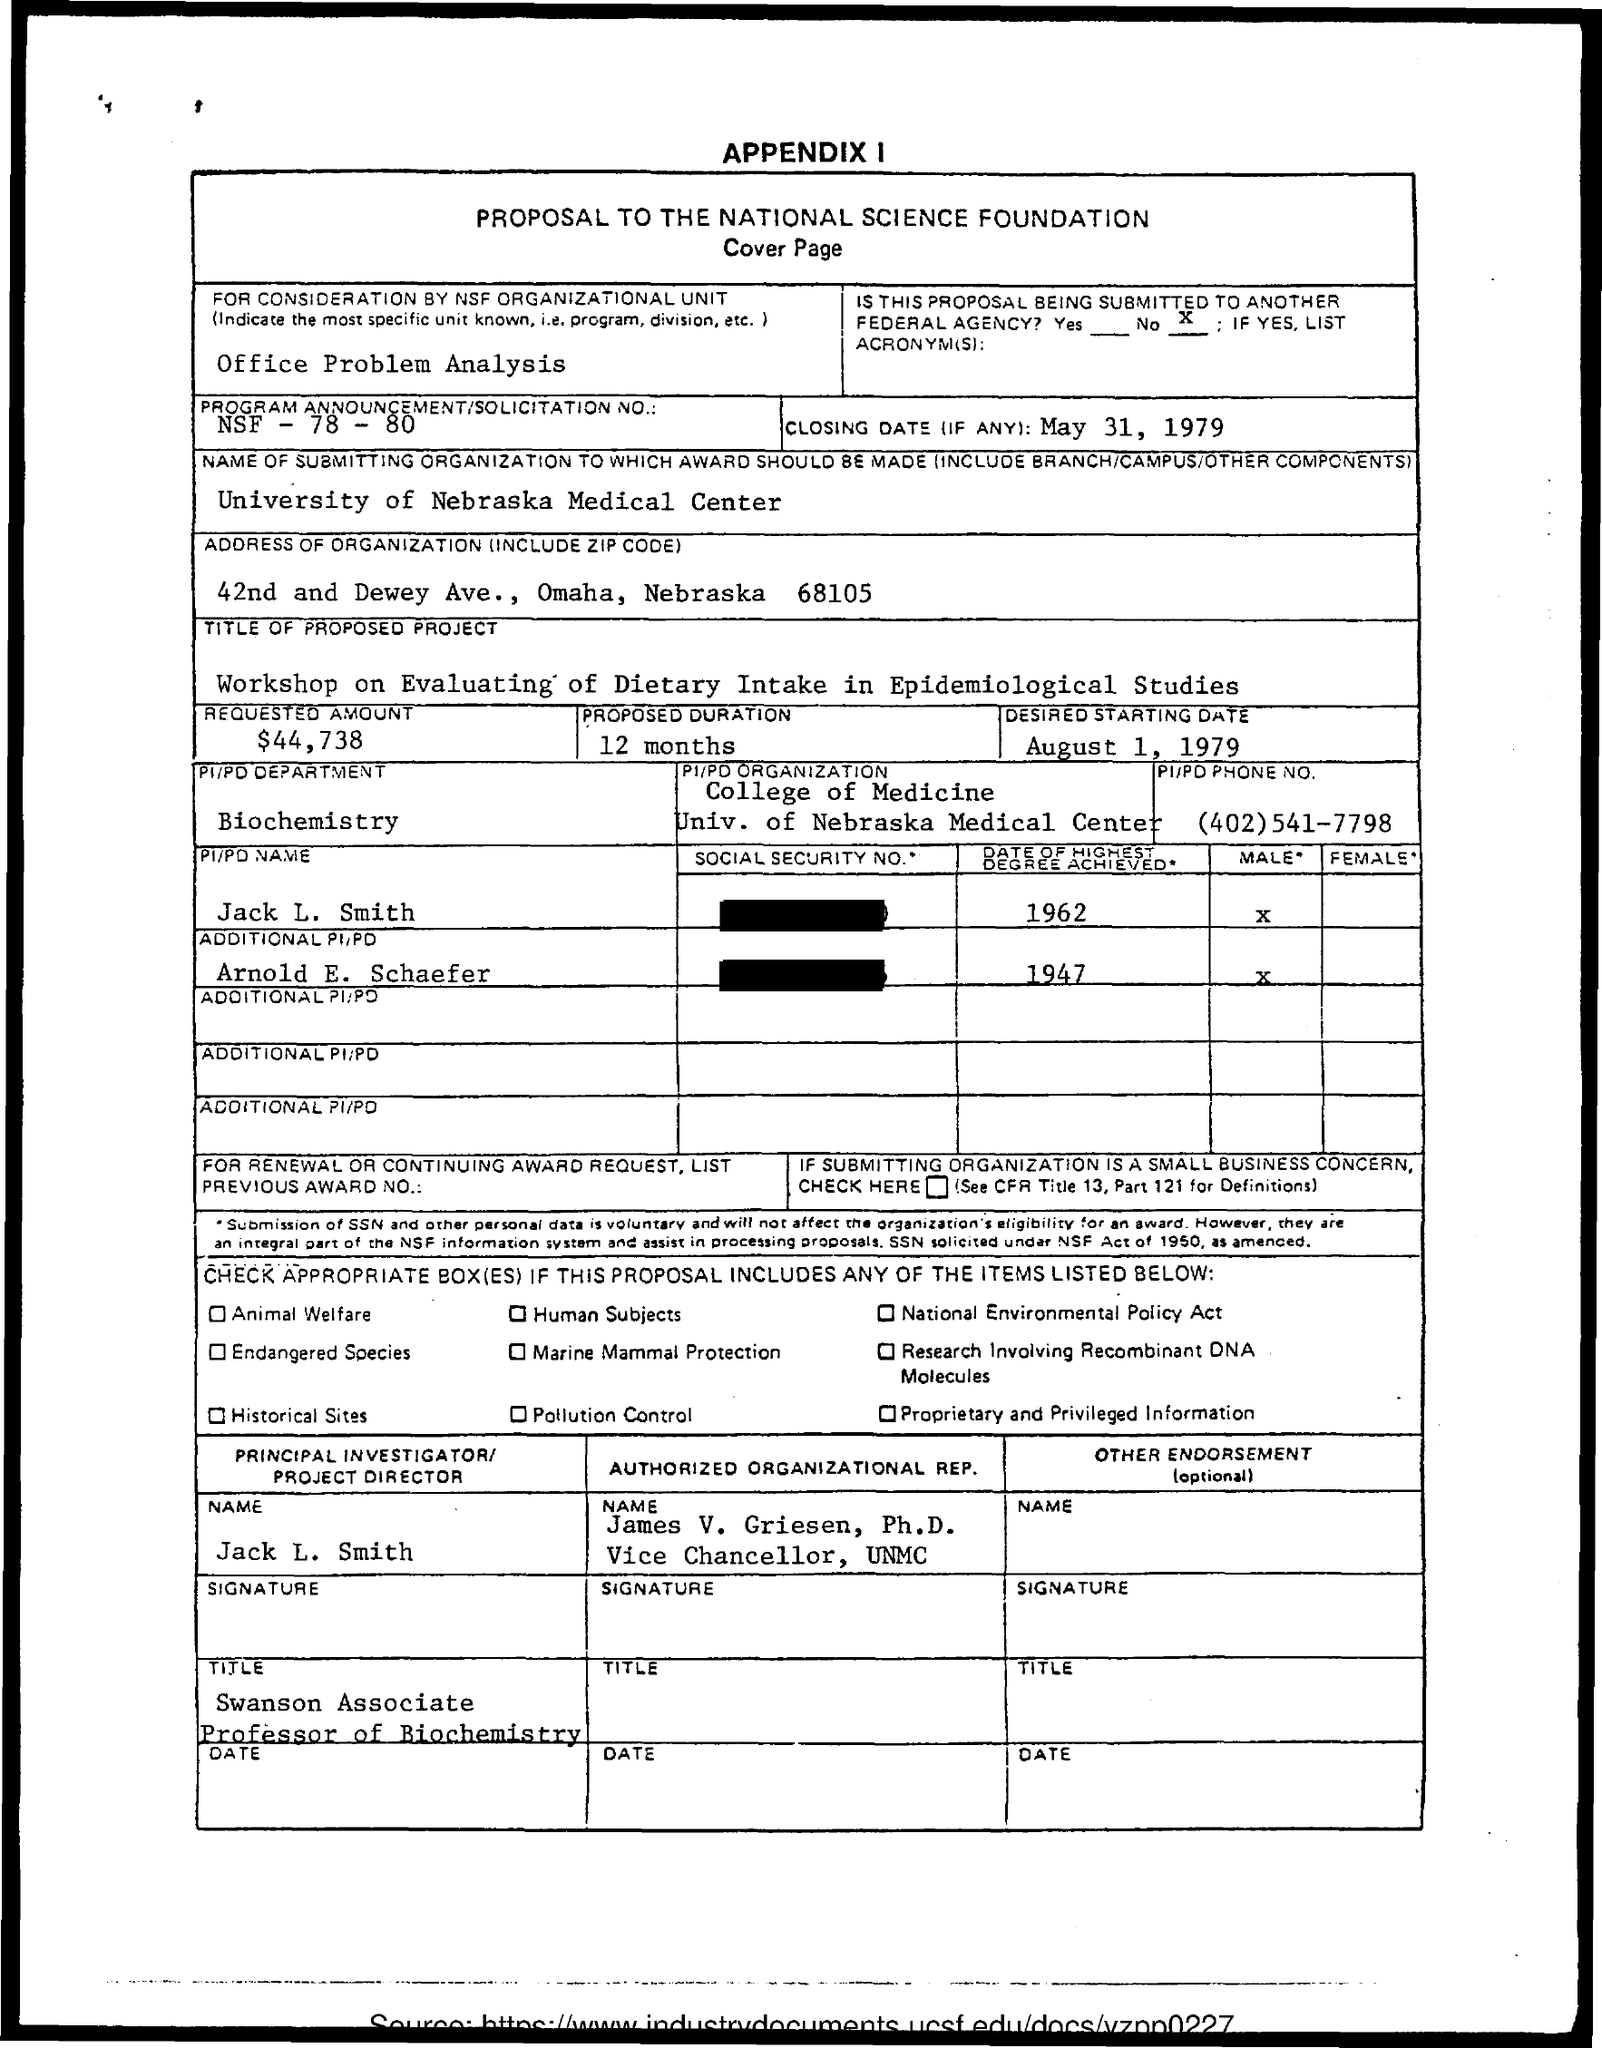What is the Program Announcement/Solicitation No.?
Your response must be concise. NSF - 78 - 80. What is the Closing date?
Your answer should be compact. May 31, 1979. What is the name of the submitting organization to which award should be made?
Your response must be concise. University of Nebraska Medical Center. What is the requested amount?
Ensure brevity in your answer.  $44,738. What is the Proposed duration?
Your response must be concise. 12 months. What is the desired starting date?
Make the answer very short. August 1, 1979. Which is the department?
Provide a short and direct response. BIOCHEMISTRY. What is the Phone No.?
Give a very brief answer. (402)541-7798. When did Jack L. Smith achieve highest degree?
Ensure brevity in your answer.  1962. When did Arnold E. Schaefer achieve highest degree?
Your answer should be very brief. 1947. 